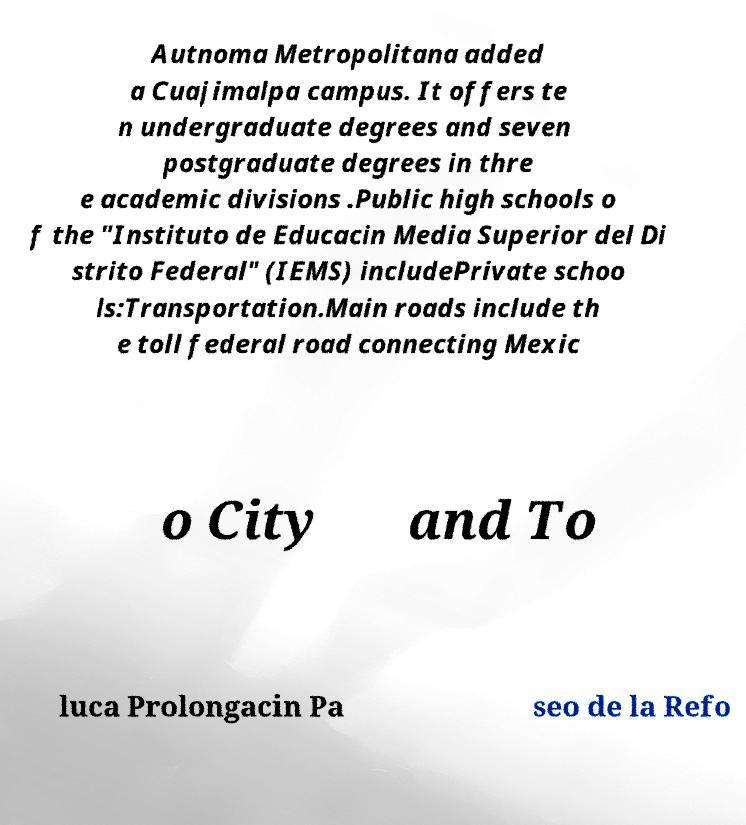For documentation purposes, I need the text within this image transcribed. Could you provide that? Autnoma Metropolitana added a Cuajimalpa campus. It offers te n undergraduate degrees and seven postgraduate degrees in thre e academic divisions .Public high schools o f the "Instituto de Educacin Media Superior del Di strito Federal" (IEMS) includePrivate schoo ls:Transportation.Main roads include th e toll federal road connecting Mexic o City and To luca Prolongacin Pa seo de la Refo 